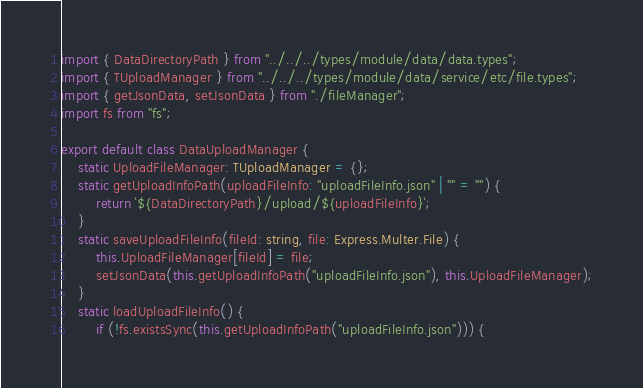<code> <loc_0><loc_0><loc_500><loc_500><_TypeScript_>import { DataDirectoryPath } from "../../../types/module/data/data.types";
import { TUploadManager } from "../../../types/module/data/service/etc/file.types";
import { getJsonData, setJsonData } from "./fileManager";
import fs from "fs";

export default class DataUploadManager {
    static UploadFileManager: TUploadManager = {};
    static getUploadInfoPath(uploadFileInfo: "uploadFileInfo.json" | "" = "") {
        return `${DataDirectoryPath}/upload/${uploadFileInfo}`;
    }
    static saveUploadFileInfo(fileId: string, file: Express.Multer.File) {
        this.UploadFileManager[fileId] = file;
        setJsonData(this.getUploadInfoPath("uploadFileInfo.json"), this.UploadFileManager);
    }
    static loadUploadFileInfo() {
        if (!fs.existsSync(this.getUploadInfoPath("uploadFileInfo.json"))) {</code> 